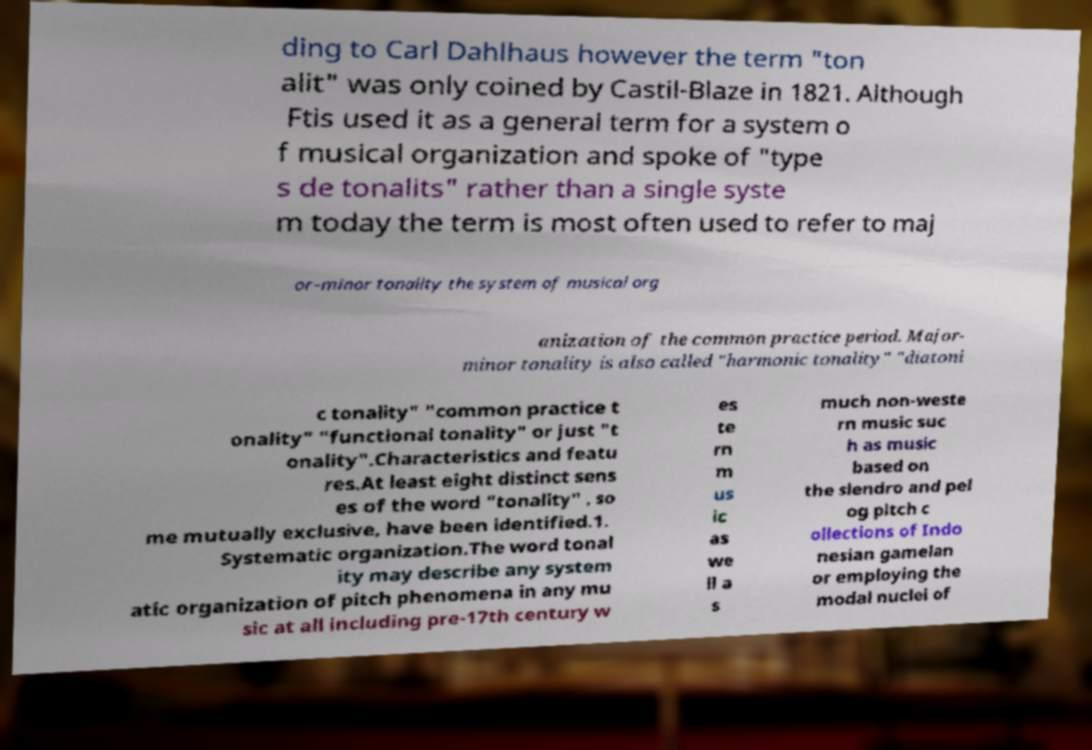I need the written content from this picture converted into text. Can you do that? ding to Carl Dahlhaus however the term "ton alit" was only coined by Castil-Blaze in 1821. Although Ftis used it as a general term for a system o f musical organization and spoke of "type s de tonalits" rather than a single syste m today the term is most often used to refer to maj or–minor tonality the system of musical org anization of the common practice period. Major- minor tonality is also called "harmonic tonality" "diatoni c tonality" "common practice t onality" "functional tonality" or just "t onality".Characteristics and featu res.At least eight distinct sens es of the word "tonality" , so me mutually exclusive, have been identified.1. Systematic organization.The word tonal ity may describe any system atic organization of pitch phenomena in any mu sic at all including pre-17th century w es te rn m us ic as we ll a s much non-weste rn music suc h as music based on the slendro and pel og pitch c ollections of Indo nesian gamelan or employing the modal nuclei of 